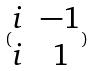<formula> <loc_0><loc_0><loc_500><loc_500>( \begin{matrix} i & - 1 \\ i & 1 \end{matrix} )</formula> 